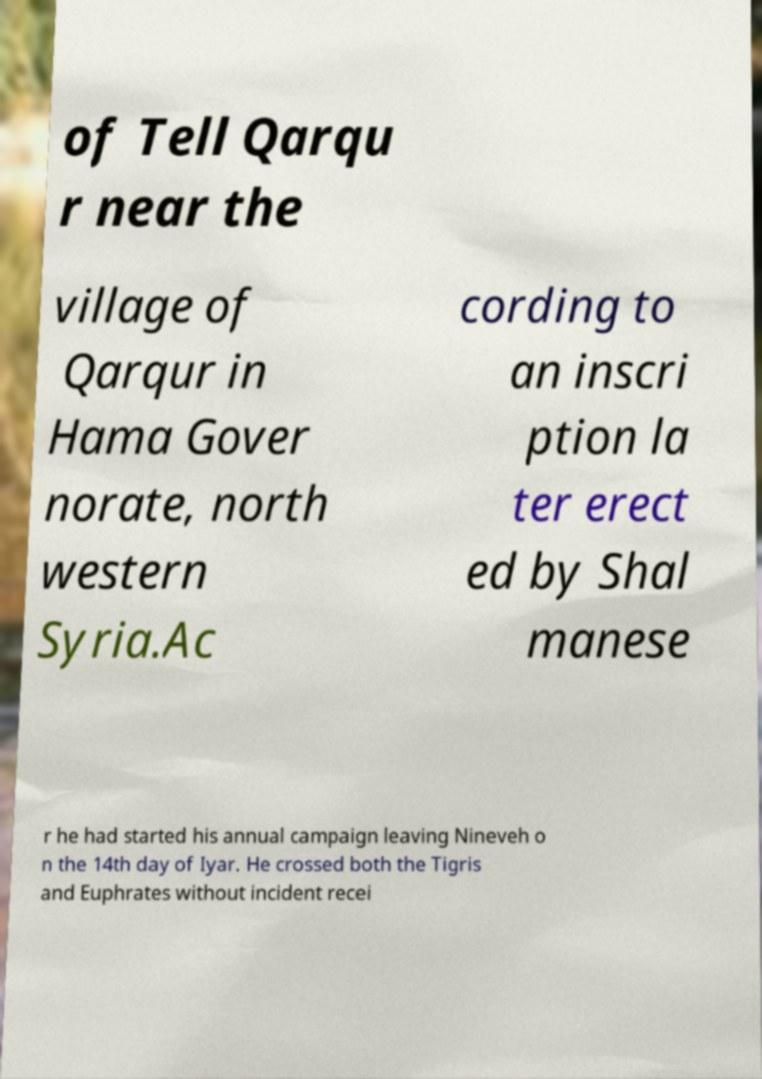There's text embedded in this image that I need extracted. Can you transcribe it verbatim? of Tell Qarqu r near the village of Qarqur in Hama Gover norate, north western Syria.Ac cording to an inscri ption la ter erect ed by Shal manese r he had started his annual campaign leaving Nineveh o n the 14th day of Iyar. He crossed both the Tigris and Euphrates without incident recei 